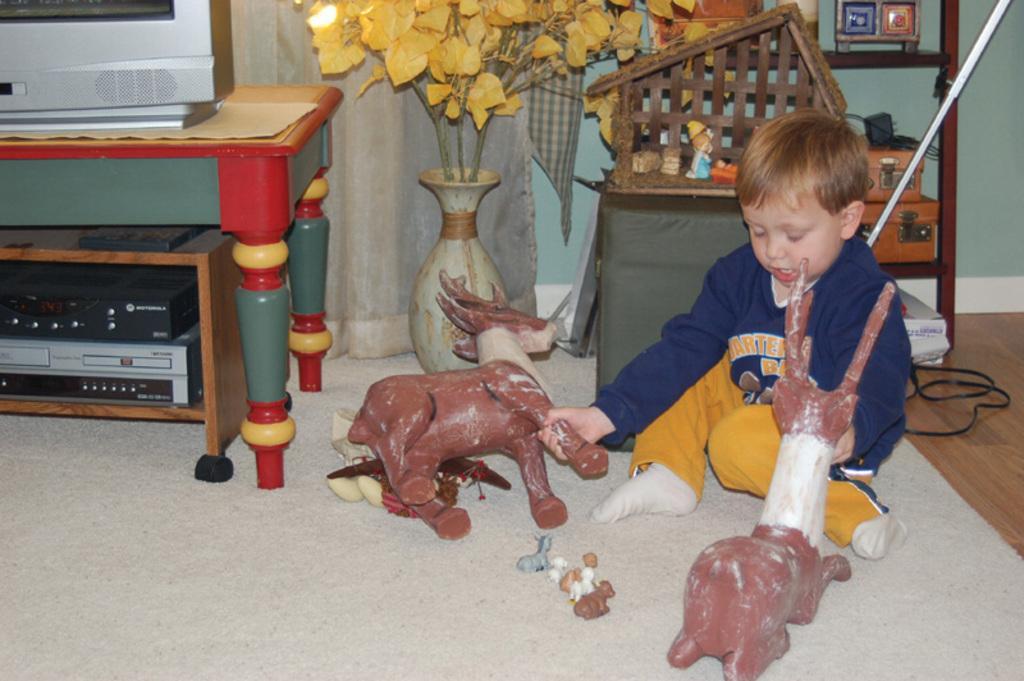Describe this image in one or two sentences. In this picture there is a boy who is playing with the toys, there is a table at the left side of the picture on which television is placed and there is a flower pot at the middle of the picture, there are some other toys at the right side of the picture behind the boy, the boy is sitting on a rug with his toys. 